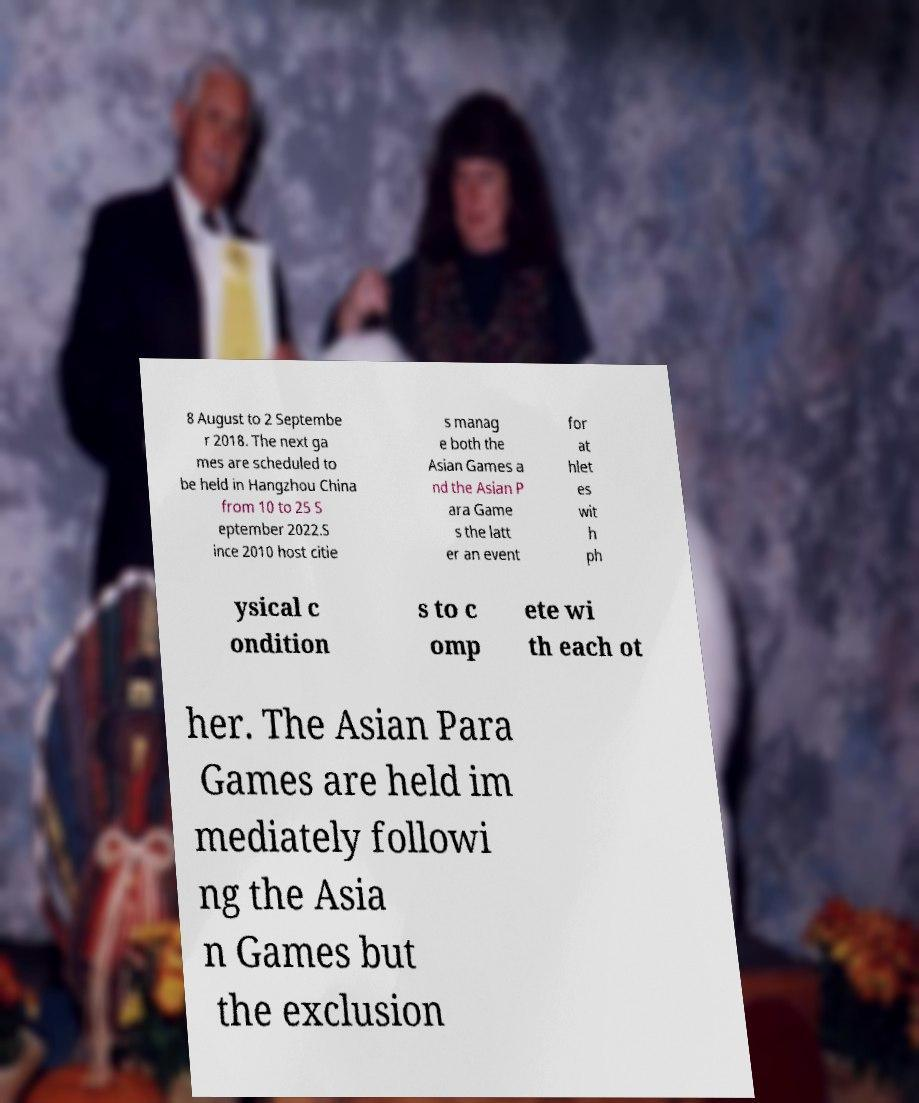Could you extract and type out the text from this image? 8 August to 2 Septembe r 2018. The next ga mes are scheduled to be held in Hangzhou China from 10 to 25 S eptember 2022.S ince 2010 host citie s manag e both the Asian Games a nd the Asian P ara Game s the latt er an event for at hlet es wit h ph ysical c ondition s to c omp ete wi th each ot her. The Asian Para Games are held im mediately followi ng the Asia n Games but the exclusion 